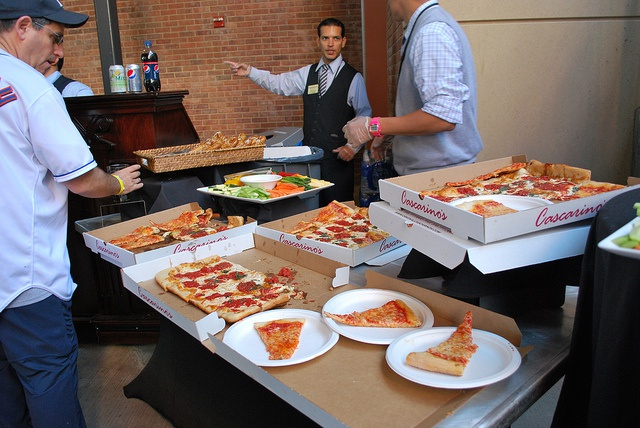Describe the objects in this image and their specific colors. I can see dining table in darkblue, lavender, darkgray, black, and tan tones, people in darkblue, lavender, navy, and black tones, people in darkblue, darkgray, gray, and lavender tones, people in darkblue, black, darkgray, and brown tones, and pizza in darkblue, lavender, tan, and red tones in this image. 